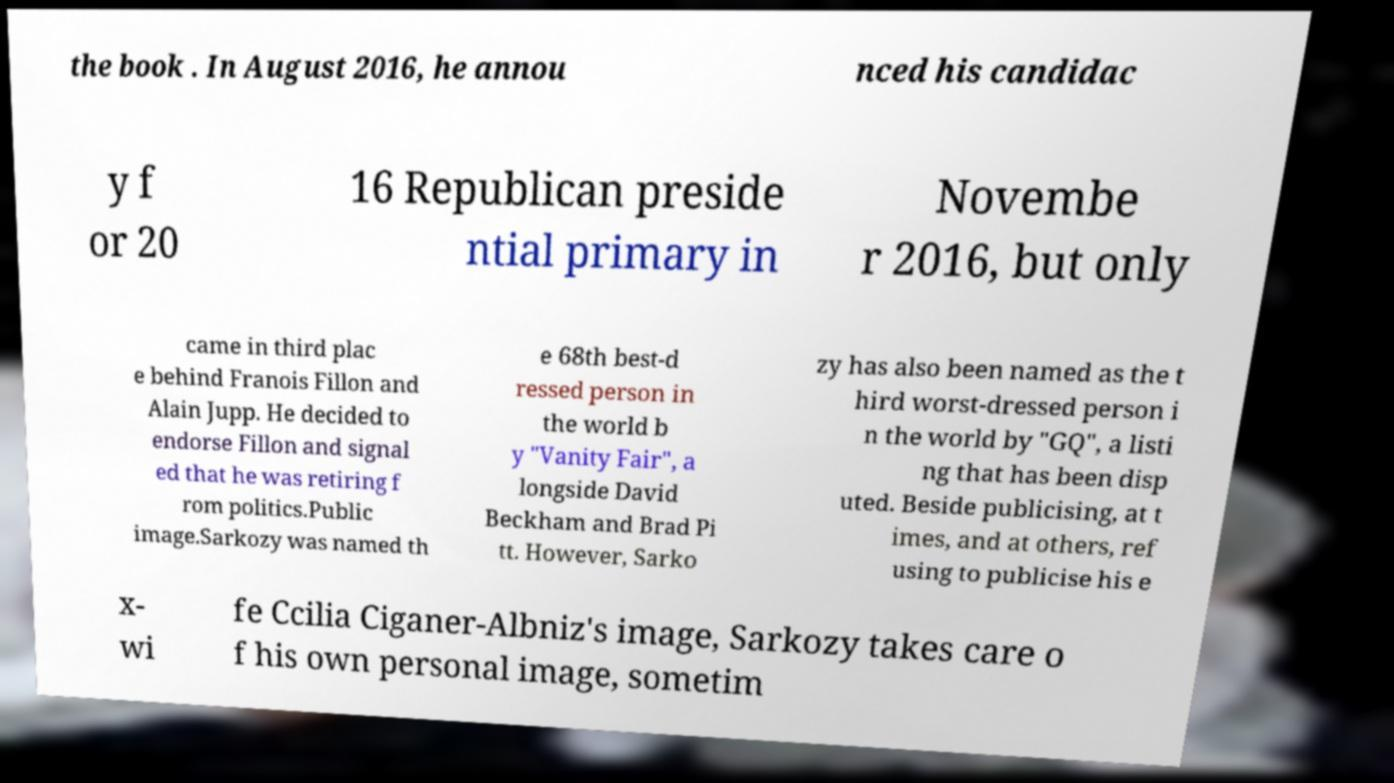Could you assist in decoding the text presented in this image and type it out clearly? the book . In August 2016, he annou nced his candidac y f or 20 16 Republican preside ntial primary in Novembe r 2016, but only came in third plac e behind Franois Fillon and Alain Jupp. He decided to endorse Fillon and signal ed that he was retiring f rom politics.Public image.Sarkozy was named th e 68th best-d ressed person in the world b y "Vanity Fair", a longside David Beckham and Brad Pi tt. However, Sarko zy has also been named as the t hird worst-dressed person i n the world by "GQ", a listi ng that has been disp uted. Beside publicising, at t imes, and at others, ref using to publicise his e x- wi fe Ccilia Ciganer-Albniz's image, Sarkozy takes care o f his own personal image, sometim 